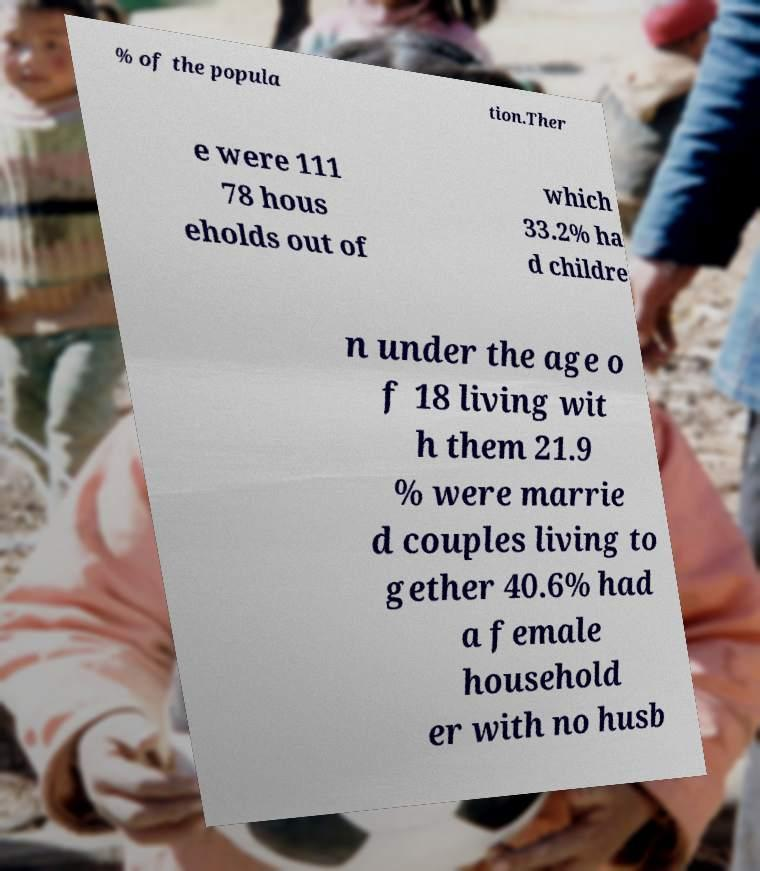For documentation purposes, I need the text within this image transcribed. Could you provide that? % of the popula tion.Ther e were 111 78 hous eholds out of which 33.2% ha d childre n under the age o f 18 living wit h them 21.9 % were marrie d couples living to gether 40.6% had a female household er with no husb 